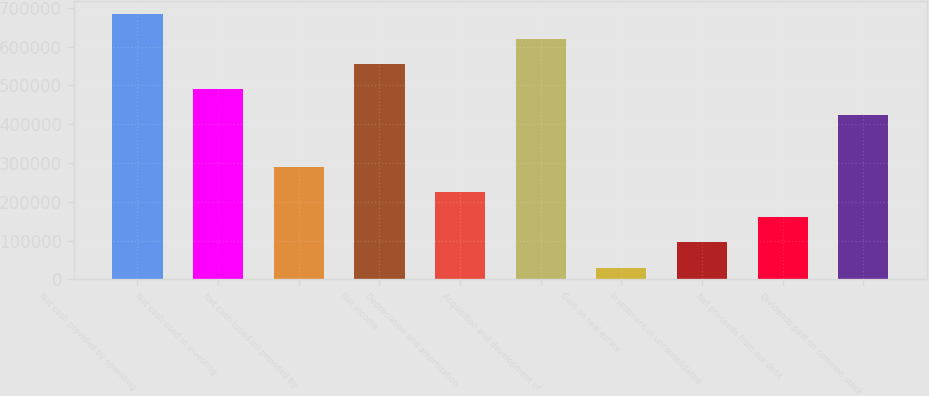Convert chart to OTSL. <chart><loc_0><loc_0><loc_500><loc_500><bar_chart><fcel>Net cash provided by operating<fcel>Net cash used in investing<fcel>Net cash (used in) provided by<fcel>Net income<fcel>Depreciation and amortization<fcel>Acquisition and development of<fcel>Gain on real estate<fcel>Investment in unconsolidated<fcel>Net proceeds from our debt<fcel>Dividends paid on common stock<nl><fcel>683702<fcel>489606<fcel>289602<fcel>554305<fcel>224903<fcel>619003<fcel>30807<fcel>95505.8<fcel>160205<fcel>424907<nl></chart> 